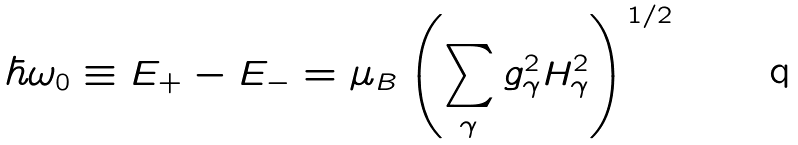Convert formula to latex. <formula><loc_0><loc_0><loc_500><loc_500>\hbar { \omega } _ { 0 } \equiv E _ { + } - E _ { - } = \mu _ { B } \left ( \sum _ { \gamma } g _ { \gamma } ^ { 2 } H _ { \gamma } ^ { 2 } \right ) ^ { 1 / 2 }</formula> 